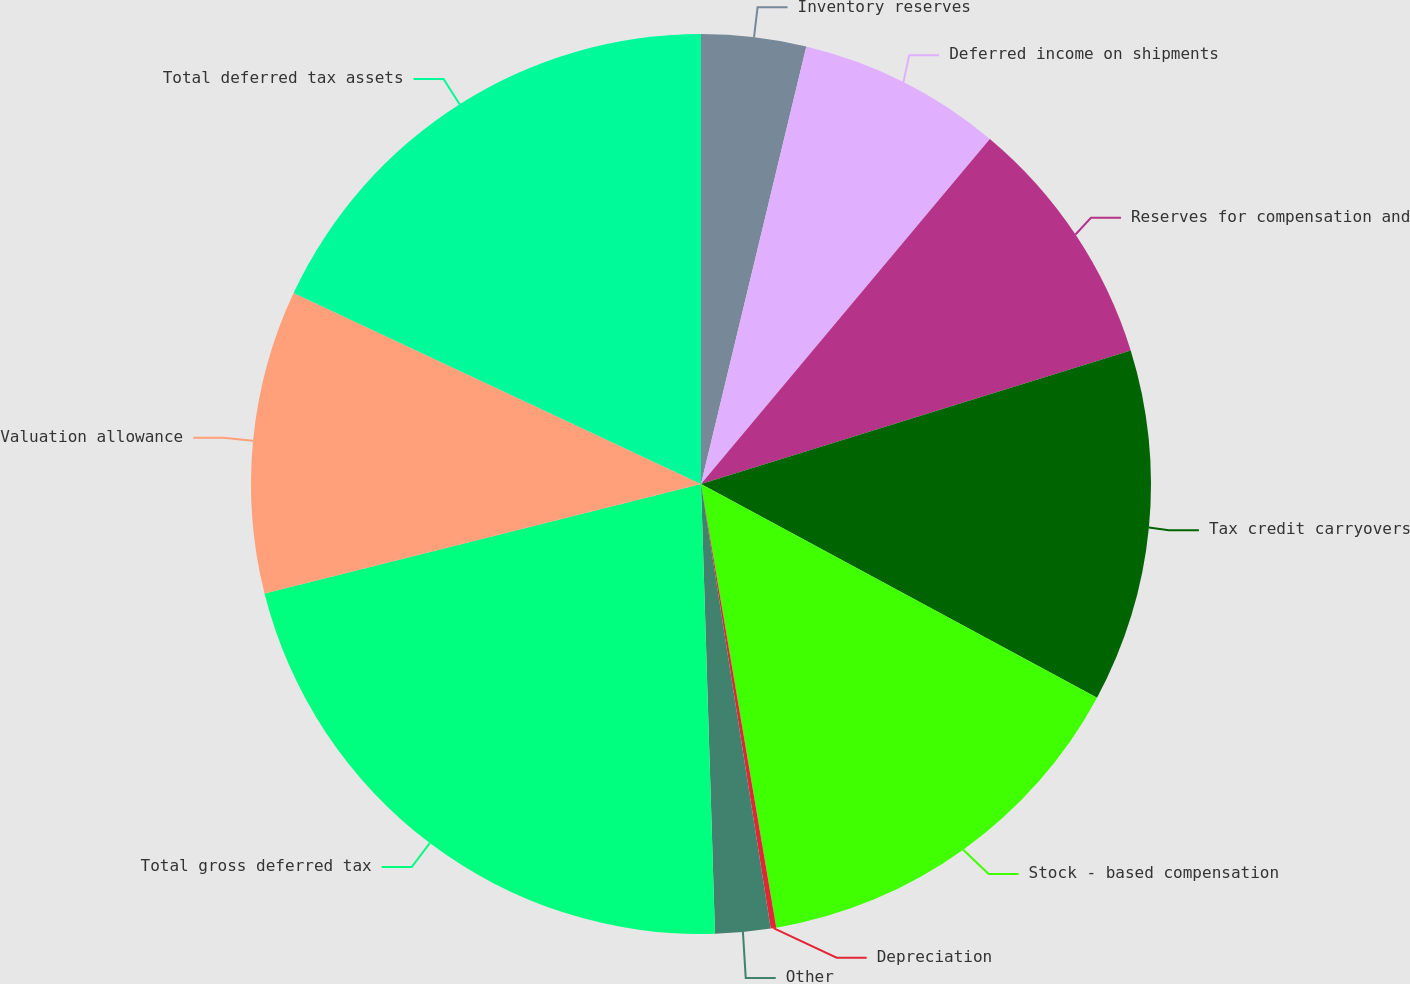Convert chart. <chart><loc_0><loc_0><loc_500><loc_500><pie_chart><fcel>Inventory reserves<fcel>Deferred income on shipments<fcel>Reserves for compensation and<fcel>Tax credit carryovers<fcel>Stock - based compensation<fcel>Depreciation<fcel>Other<fcel>Total gross deferred tax<fcel>Valuation allowance<fcel>Total deferred tax assets<nl><fcel>3.76%<fcel>7.33%<fcel>9.11%<fcel>12.67%<fcel>14.45%<fcel>0.2%<fcel>1.98%<fcel>21.58%<fcel>10.89%<fcel>18.02%<nl></chart> 